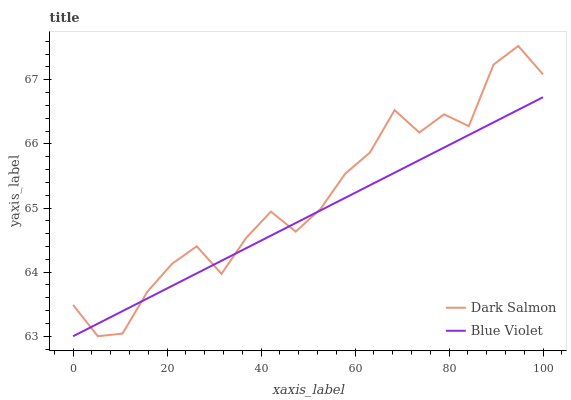Does Blue Violet have the minimum area under the curve?
Answer yes or no. Yes. Does Dark Salmon have the maximum area under the curve?
Answer yes or no. Yes. Does Blue Violet have the maximum area under the curve?
Answer yes or no. No. Is Blue Violet the smoothest?
Answer yes or no. Yes. Is Dark Salmon the roughest?
Answer yes or no. Yes. Is Blue Violet the roughest?
Answer yes or no. No. Does Dark Salmon have the lowest value?
Answer yes or no. Yes. Does Dark Salmon have the highest value?
Answer yes or no. Yes. Does Blue Violet have the highest value?
Answer yes or no. No. Does Blue Violet intersect Dark Salmon?
Answer yes or no. Yes. Is Blue Violet less than Dark Salmon?
Answer yes or no. No. Is Blue Violet greater than Dark Salmon?
Answer yes or no. No. 